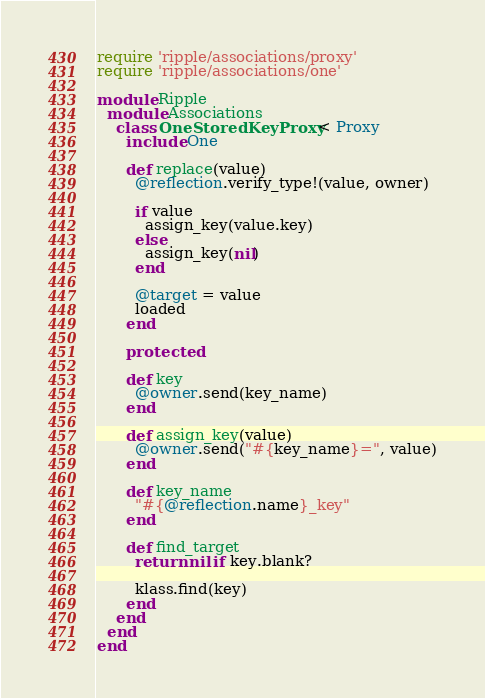Convert code to text. <code><loc_0><loc_0><loc_500><loc_500><_Ruby_>require 'ripple/associations/proxy'
require 'ripple/associations/one'

module Ripple
  module Associations
    class OneStoredKeyProxy < Proxy
      include One

      def replace(value)
        @reflection.verify_type!(value, owner)

        if value
          assign_key(value.key)
        else
          assign_key(nil)
        end

        @target = value
        loaded
      end

      protected

      def key
        @owner.send(key_name)
      end

      def assign_key(value)
        @owner.send("#{key_name}=", value)
      end

      def key_name
        "#{@reflection.name}_key"
      end

      def find_target
        return nil if key.blank?

        klass.find(key)
      end
    end
  end
end</code> 